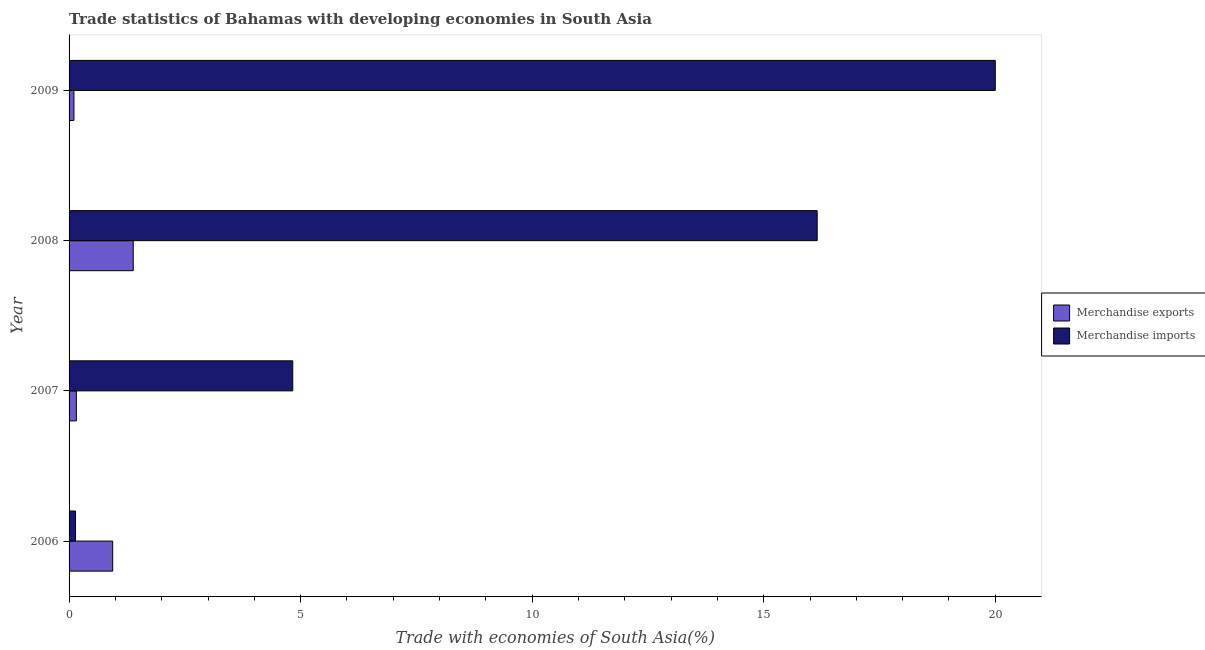Are the number of bars on each tick of the Y-axis equal?
Offer a terse response. Yes. How many bars are there on the 2nd tick from the top?
Your answer should be compact. 2. What is the label of the 4th group of bars from the top?
Provide a succinct answer. 2006. What is the merchandise exports in 2007?
Offer a terse response. 0.16. Across all years, what is the maximum merchandise exports?
Provide a short and direct response. 1.39. Across all years, what is the minimum merchandise imports?
Provide a succinct answer. 0.14. In which year was the merchandise imports minimum?
Provide a short and direct response. 2006. What is the total merchandise exports in the graph?
Keep it short and to the point. 2.59. What is the difference between the merchandise imports in 2008 and that in 2009?
Your answer should be very brief. -3.85. What is the difference between the merchandise imports in 2009 and the merchandise exports in 2008?
Ensure brevity in your answer.  18.61. What is the average merchandise imports per year?
Ensure brevity in your answer.  10.28. In the year 2008, what is the difference between the merchandise exports and merchandise imports?
Provide a short and direct response. -14.77. In how many years, is the merchandise exports greater than 13 %?
Provide a short and direct response. 0. What is the ratio of the merchandise imports in 2007 to that in 2008?
Offer a very short reply. 0.3. Is the difference between the merchandise exports in 2008 and 2009 greater than the difference between the merchandise imports in 2008 and 2009?
Give a very brief answer. Yes. What is the difference between the highest and the second highest merchandise imports?
Ensure brevity in your answer.  3.85. What is the difference between the highest and the lowest merchandise exports?
Make the answer very short. 1.28. In how many years, is the merchandise exports greater than the average merchandise exports taken over all years?
Offer a very short reply. 2. Is the sum of the merchandise imports in 2007 and 2008 greater than the maximum merchandise exports across all years?
Keep it short and to the point. Yes. What does the 1st bar from the top in 2008 represents?
Your answer should be compact. Merchandise imports. What does the 1st bar from the bottom in 2008 represents?
Your response must be concise. Merchandise exports. How many bars are there?
Your answer should be compact. 8. Are all the bars in the graph horizontal?
Provide a succinct answer. Yes. How many years are there in the graph?
Offer a terse response. 4. Are the values on the major ticks of X-axis written in scientific E-notation?
Keep it short and to the point. No. Where does the legend appear in the graph?
Make the answer very short. Center right. How many legend labels are there?
Ensure brevity in your answer.  2. How are the legend labels stacked?
Ensure brevity in your answer.  Vertical. What is the title of the graph?
Provide a short and direct response. Trade statistics of Bahamas with developing economies in South Asia. What is the label or title of the X-axis?
Keep it short and to the point. Trade with economies of South Asia(%). What is the Trade with economies of South Asia(%) in Merchandise exports in 2006?
Your answer should be compact. 0.94. What is the Trade with economies of South Asia(%) of Merchandise imports in 2006?
Your answer should be compact. 0.14. What is the Trade with economies of South Asia(%) of Merchandise exports in 2007?
Give a very brief answer. 0.16. What is the Trade with economies of South Asia(%) in Merchandise imports in 2007?
Keep it short and to the point. 4.83. What is the Trade with economies of South Asia(%) of Merchandise exports in 2008?
Provide a short and direct response. 1.39. What is the Trade with economies of South Asia(%) of Merchandise imports in 2008?
Provide a succinct answer. 16.15. What is the Trade with economies of South Asia(%) of Merchandise exports in 2009?
Provide a short and direct response. 0.11. What is the Trade with economies of South Asia(%) of Merchandise imports in 2009?
Offer a terse response. 20. Across all years, what is the maximum Trade with economies of South Asia(%) in Merchandise exports?
Make the answer very short. 1.39. Across all years, what is the maximum Trade with economies of South Asia(%) of Merchandise imports?
Make the answer very short. 20. Across all years, what is the minimum Trade with economies of South Asia(%) in Merchandise exports?
Offer a terse response. 0.11. Across all years, what is the minimum Trade with economies of South Asia(%) in Merchandise imports?
Your answer should be very brief. 0.14. What is the total Trade with economies of South Asia(%) in Merchandise exports in the graph?
Your answer should be very brief. 2.59. What is the total Trade with economies of South Asia(%) of Merchandise imports in the graph?
Give a very brief answer. 41.12. What is the difference between the Trade with economies of South Asia(%) of Merchandise exports in 2006 and that in 2007?
Provide a succinct answer. 0.78. What is the difference between the Trade with economies of South Asia(%) of Merchandise imports in 2006 and that in 2007?
Your response must be concise. -4.69. What is the difference between the Trade with economies of South Asia(%) of Merchandise exports in 2006 and that in 2008?
Offer a terse response. -0.44. What is the difference between the Trade with economies of South Asia(%) of Merchandise imports in 2006 and that in 2008?
Keep it short and to the point. -16.01. What is the difference between the Trade with economies of South Asia(%) of Merchandise exports in 2006 and that in 2009?
Your response must be concise. 0.84. What is the difference between the Trade with economies of South Asia(%) in Merchandise imports in 2006 and that in 2009?
Your answer should be compact. -19.86. What is the difference between the Trade with economies of South Asia(%) in Merchandise exports in 2007 and that in 2008?
Your answer should be compact. -1.23. What is the difference between the Trade with economies of South Asia(%) of Merchandise imports in 2007 and that in 2008?
Your response must be concise. -11.32. What is the difference between the Trade with economies of South Asia(%) of Merchandise exports in 2007 and that in 2009?
Make the answer very short. 0.05. What is the difference between the Trade with economies of South Asia(%) of Merchandise imports in 2007 and that in 2009?
Offer a terse response. -15.17. What is the difference between the Trade with economies of South Asia(%) in Merchandise exports in 2008 and that in 2009?
Offer a very short reply. 1.28. What is the difference between the Trade with economies of South Asia(%) of Merchandise imports in 2008 and that in 2009?
Your response must be concise. -3.85. What is the difference between the Trade with economies of South Asia(%) in Merchandise exports in 2006 and the Trade with economies of South Asia(%) in Merchandise imports in 2007?
Provide a succinct answer. -3.89. What is the difference between the Trade with economies of South Asia(%) in Merchandise exports in 2006 and the Trade with economies of South Asia(%) in Merchandise imports in 2008?
Provide a succinct answer. -15.21. What is the difference between the Trade with economies of South Asia(%) of Merchandise exports in 2006 and the Trade with economies of South Asia(%) of Merchandise imports in 2009?
Provide a succinct answer. -19.06. What is the difference between the Trade with economies of South Asia(%) in Merchandise exports in 2007 and the Trade with economies of South Asia(%) in Merchandise imports in 2008?
Offer a terse response. -16. What is the difference between the Trade with economies of South Asia(%) in Merchandise exports in 2007 and the Trade with economies of South Asia(%) in Merchandise imports in 2009?
Ensure brevity in your answer.  -19.84. What is the difference between the Trade with economies of South Asia(%) in Merchandise exports in 2008 and the Trade with economies of South Asia(%) in Merchandise imports in 2009?
Make the answer very short. -18.61. What is the average Trade with economies of South Asia(%) in Merchandise exports per year?
Provide a succinct answer. 0.65. What is the average Trade with economies of South Asia(%) in Merchandise imports per year?
Provide a succinct answer. 10.28. In the year 2006, what is the difference between the Trade with economies of South Asia(%) in Merchandise exports and Trade with economies of South Asia(%) in Merchandise imports?
Make the answer very short. 0.8. In the year 2007, what is the difference between the Trade with economies of South Asia(%) in Merchandise exports and Trade with economies of South Asia(%) in Merchandise imports?
Make the answer very short. -4.67. In the year 2008, what is the difference between the Trade with economies of South Asia(%) in Merchandise exports and Trade with economies of South Asia(%) in Merchandise imports?
Make the answer very short. -14.77. In the year 2009, what is the difference between the Trade with economies of South Asia(%) of Merchandise exports and Trade with economies of South Asia(%) of Merchandise imports?
Your answer should be very brief. -19.89. What is the ratio of the Trade with economies of South Asia(%) of Merchandise exports in 2006 to that in 2007?
Make the answer very short. 5.98. What is the ratio of the Trade with economies of South Asia(%) of Merchandise imports in 2006 to that in 2007?
Your answer should be compact. 0.03. What is the ratio of the Trade with economies of South Asia(%) in Merchandise exports in 2006 to that in 2008?
Your response must be concise. 0.68. What is the ratio of the Trade with economies of South Asia(%) of Merchandise imports in 2006 to that in 2008?
Your response must be concise. 0.01. What is the ratio of the Trade with economies of South Asia(%) in Merchandise exports in 2006 to that in 2009?
Make the answer very short. 8.95. What is the ratio of the Trade with economies of South Asia(%) in Merchandise imports in 2006 to that in 2009?
Ensure brevity in your answer.  0.01. What is the ratio of the Trade with economies of South Asia(%) of Merchandise exports in 2007 to that in 2008?
Offer a very short reply. 0.11. What is the ratio of the Trade with economies of South Asia(%) in Merchandise imports in 2007 to that in 2008?
Ensure brevity in your answer.  0.3. What is the ratio of the Trade with economies of South Asia(%) of Merchandise exports in 2007 to that in 2009?
Offer a terse response. 1.5. What is the ratio of the Trade with economies of South Asia(%) in Merchandise imports in 2007 to that in 2009?
Ensure brevity in your answer.  0.24. What is the ratio of the Trade with economies of South Asia(%) in Merchandise exports in 2008 to that in 2009?
Ensure brevity in your answer.  13.17. What is the ratio of the Trade with economies of South Asia(%) of Merchandise imports in 2008 to that in 2009?
Provide a short and direct response. 0.81. What is the difference between the highest and the second highest Trade with economies of South Asia(%) in Merchandise exports?
Ensure brevity in your answer.  0.44. What is the difference between the highest and the second highest Trade with economies of South Asia(%) of Merchandise imports?
Make the answer very short. 3.85. What is the difference between the highest and the lowest Trade with economies of South Asia(%) in Merchandise exports?
Keep it short and to the point. 1.28. What is the difference between the highest and the lowest Trade with economies of South Asia(%) of Merchandise imports?
Ensure brevity in your answer.  19.86. 